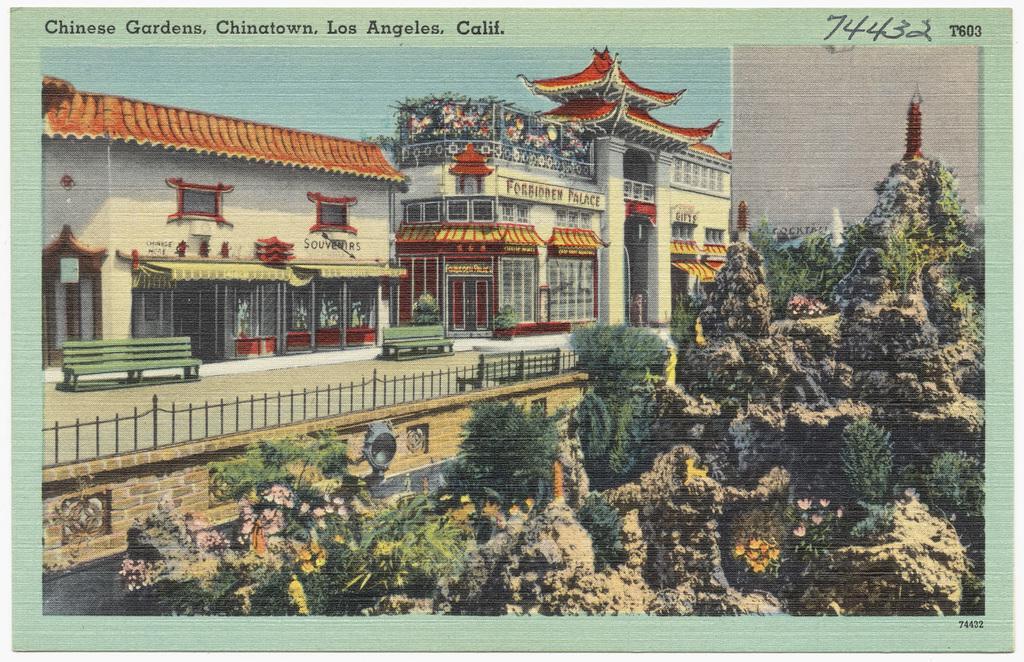Can you describe this image briefly? In the picture we can see a painting with a number of trees and beside it, we can see some rock hill beside it, we can see a railing and behind it, we can see a path and some benches and behind it we can see some buildings with shops and behind it we can see a sky. 